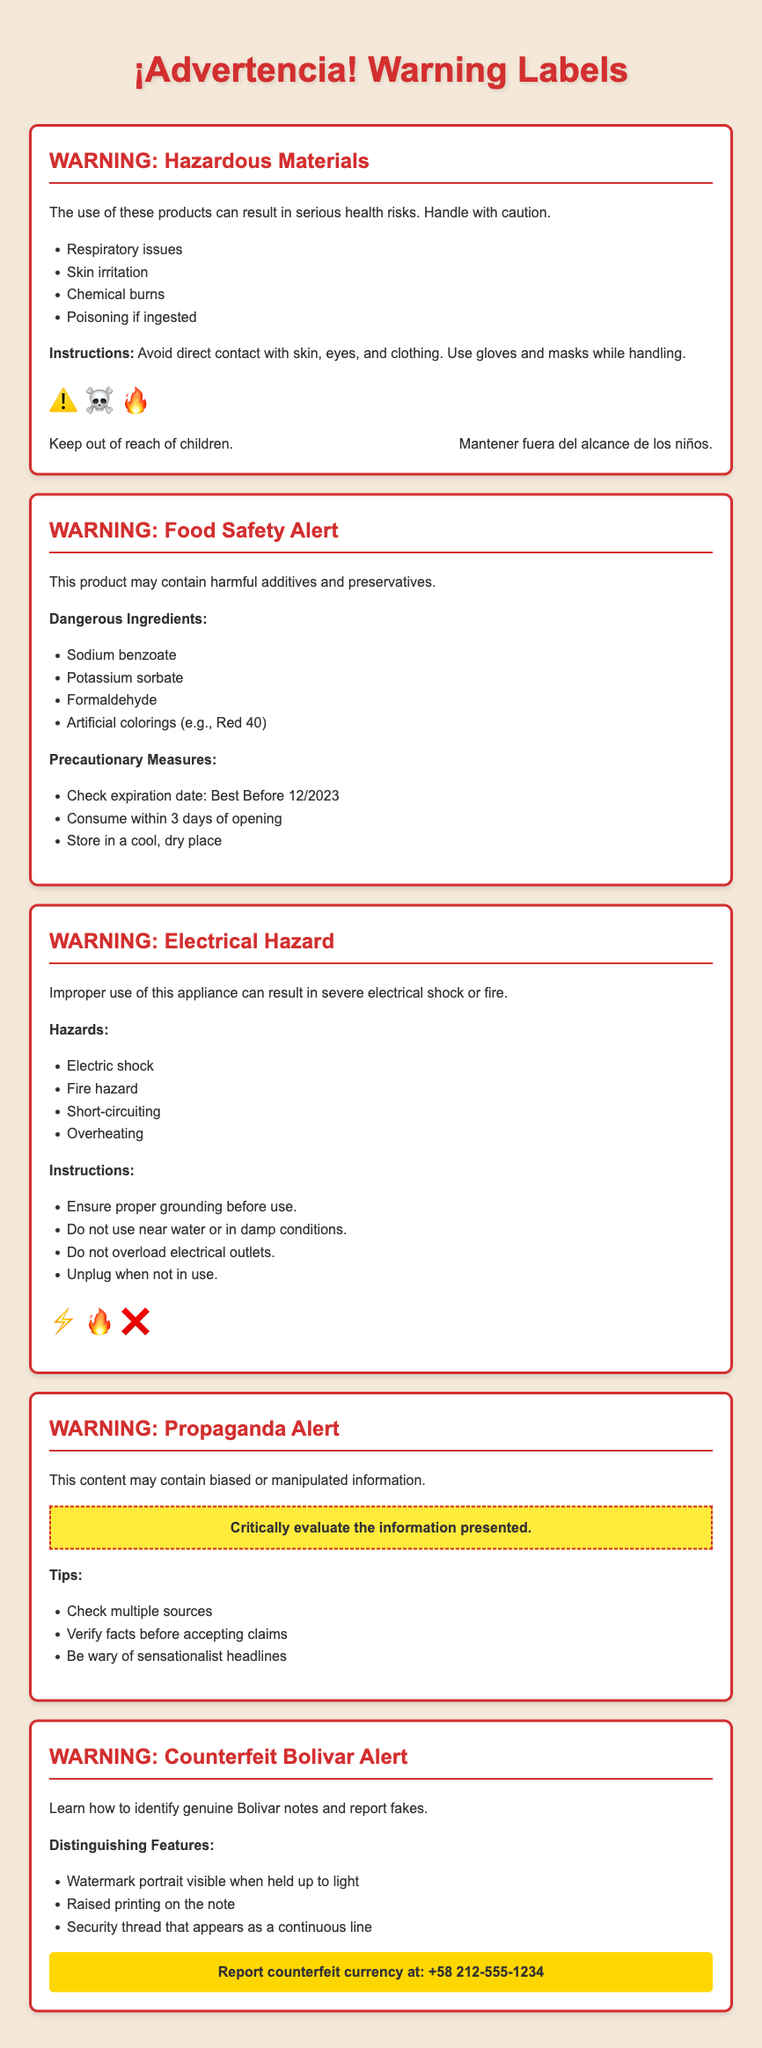What are the health risks associated with hazardous materials? The health risks listed in the document include respiratory issues, skin irritation, chemical burns, and poisoning if ingested.
Answer: Respiratory issues, skin irritation, chemical burns, poisoning What is the expiration date for the food safety alert? The expiration date mentioned for the food safety alert is "Best Before 12/2023."
Answer: Best Before 12/2023 What precaution should be taken when using electrical appliances? The document emphasizes ensuring proper grounding before use as a critical precaution.
Answer: Ensure proper grounding What should you look for to identify counterfeit Bolivar notes? Key distinguishing features listed include watermark portrait visible when held up to light, raised printing, and a security thread.
Answer: Watermark portrait What alert is provided regarding political content? The document warns that the political content may contain biased or manipulated information.
Answer: Biased or manipulated information What is the hotline number for reporting counterfeit currency? The hotline number provided in the document for reporting counterfeit currency is +58 212-555-1234.
Answer: +58 212-555-1234 How many dangerous ingredients are listed on the food safety alert? Four harmful ingredients are listed under the food safety alert.
Answer: Four What warning symbols are associated with hazardous materials? The hazardous materials section includes three symbols: ⚠️ ☠️ 🔥.
Answer: ⚠️ ☠️ 🔥 What should you do when not using an electrical appliance? The document advises to unplug the appliance when not in use.
Answer: Unplug when not in use 